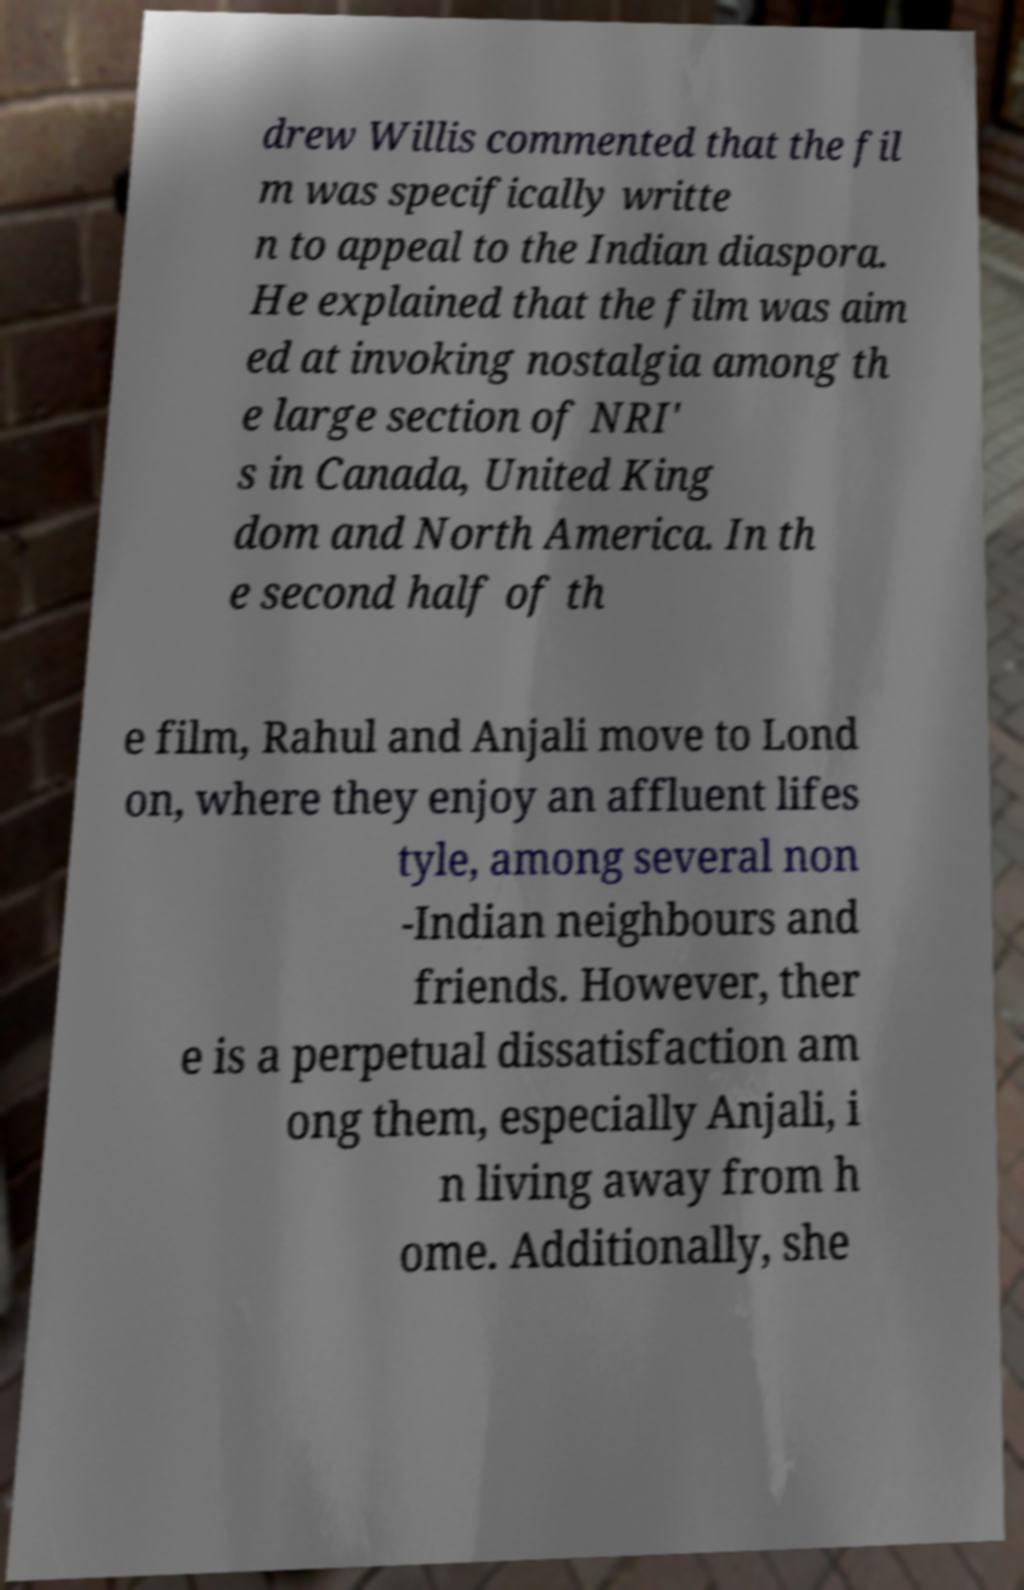What messages or text are displayed in this image? I need them in a readable, typed format. drew Willis commented that the fil m was specifically writte n to appeal to the Indian diaspora. He explained that the film was aim ed at invoking nostalgia among th e large section of NRI' s in Canada, United King dom and North America. In th e second half of th e film, Rahul and Anjali move to Lond on, where they enjoy an affluent lifes tyle, among several non -Indian neighbours and friends. However, ther e is a perpetual dissatisfaction am ong them, especially Anjali, i n living away from h ome. Additionally, she 